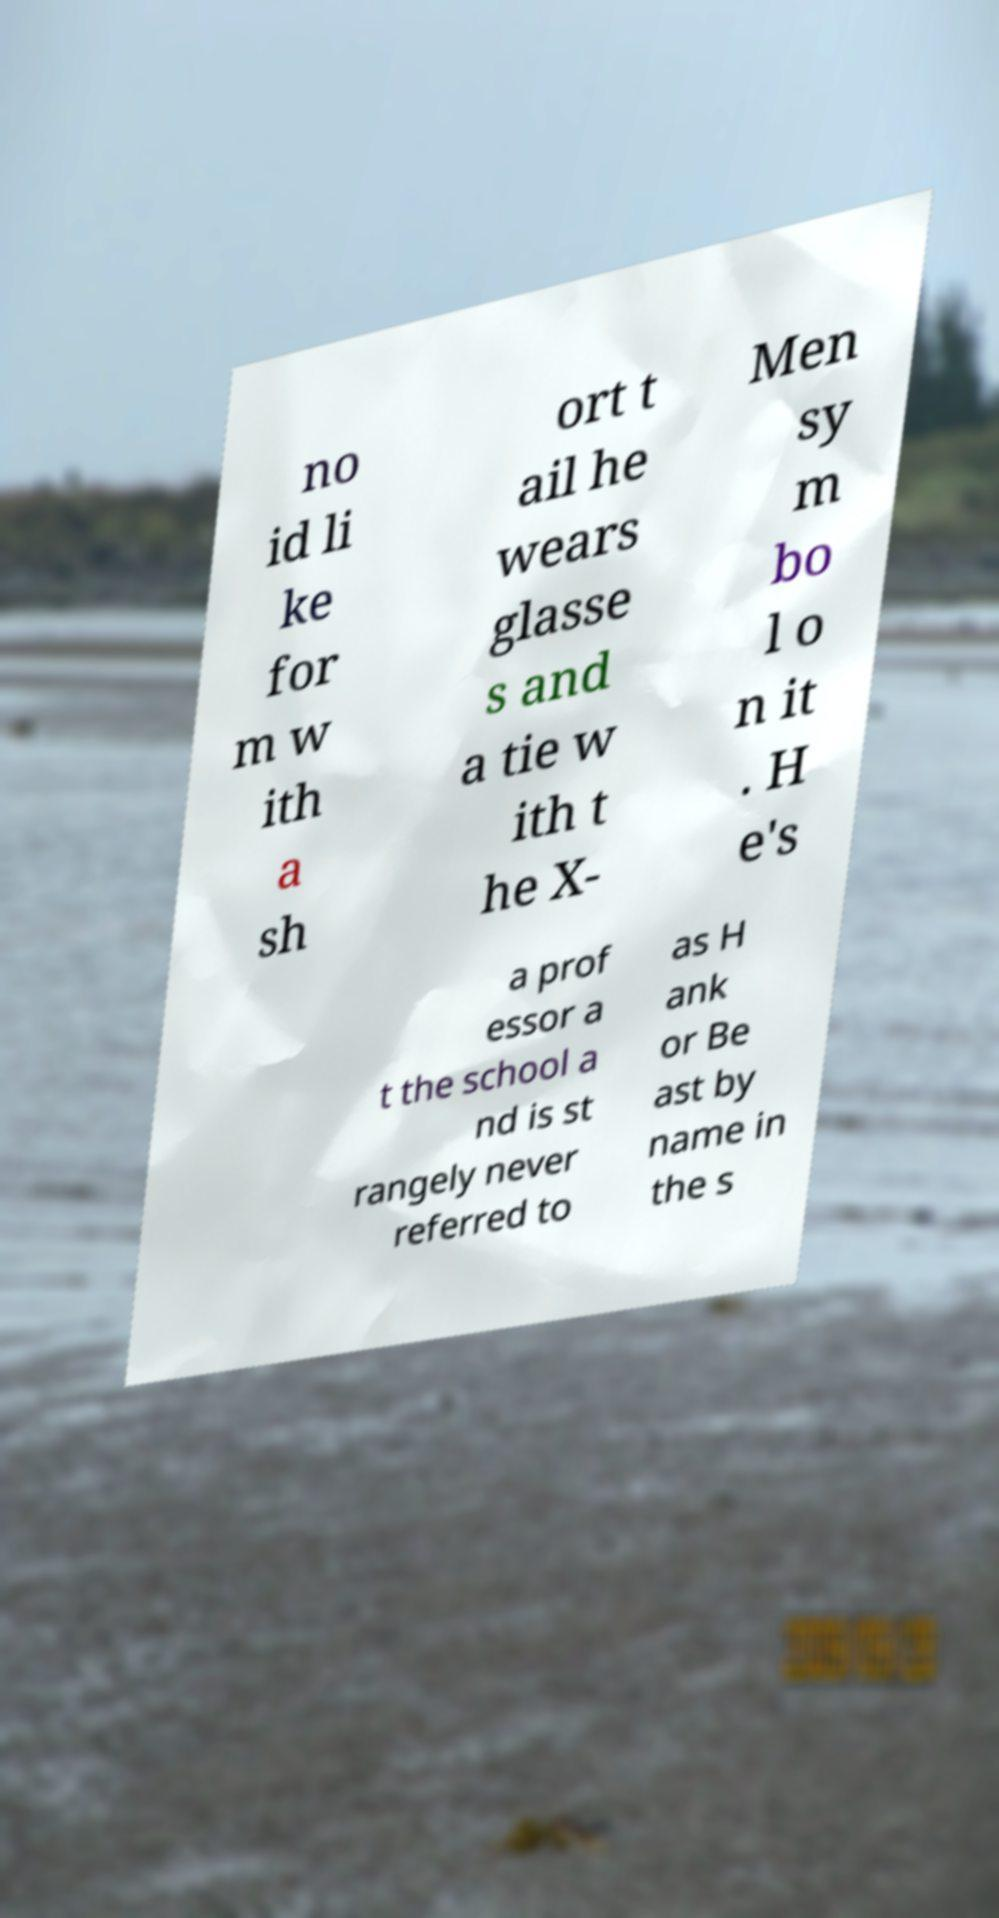For documentation purposes, I need the text within this image transcribed. Could you provide that? no id li ke for m w ith a sh ort t ail he wears glasse s and a tie w ith t he X- Men sy m bo l o n it . H e's a prof essor a t the school a nd is st rangely never referred to as H ank or Be ast by name in the s 